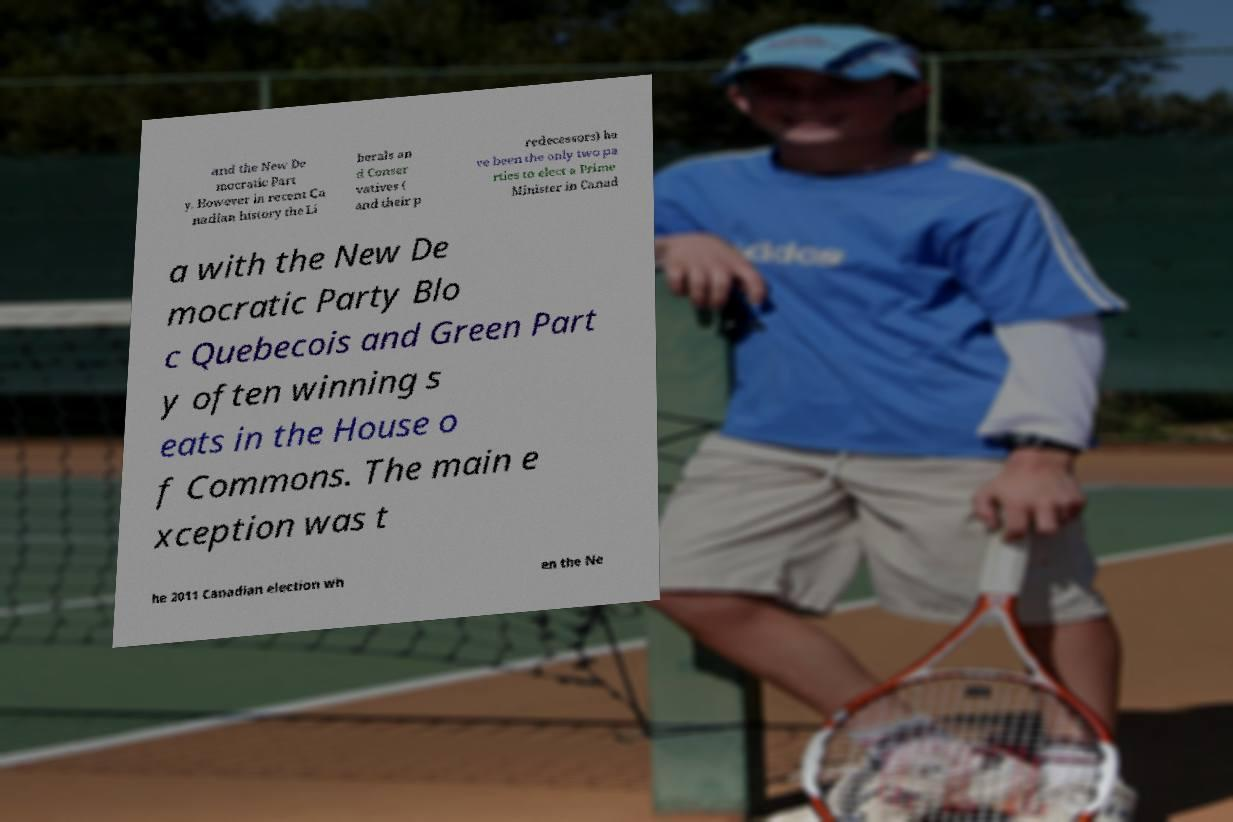What messages or text are displayed in this image? I need them in a readable, typed format. and the New De mocratic Part y. However in recent Ca nadian history the Li berals an d Conser vatives ( and their p redecessors) ha ve been the only two pa rties to elect a Prime Minister in Canad a with the New De mocratic Party Blo c Quebecois and Green Part y often winning s eats in the House o f Commons. The main e xception was t he 2011 Canadian election wh en the Ne 